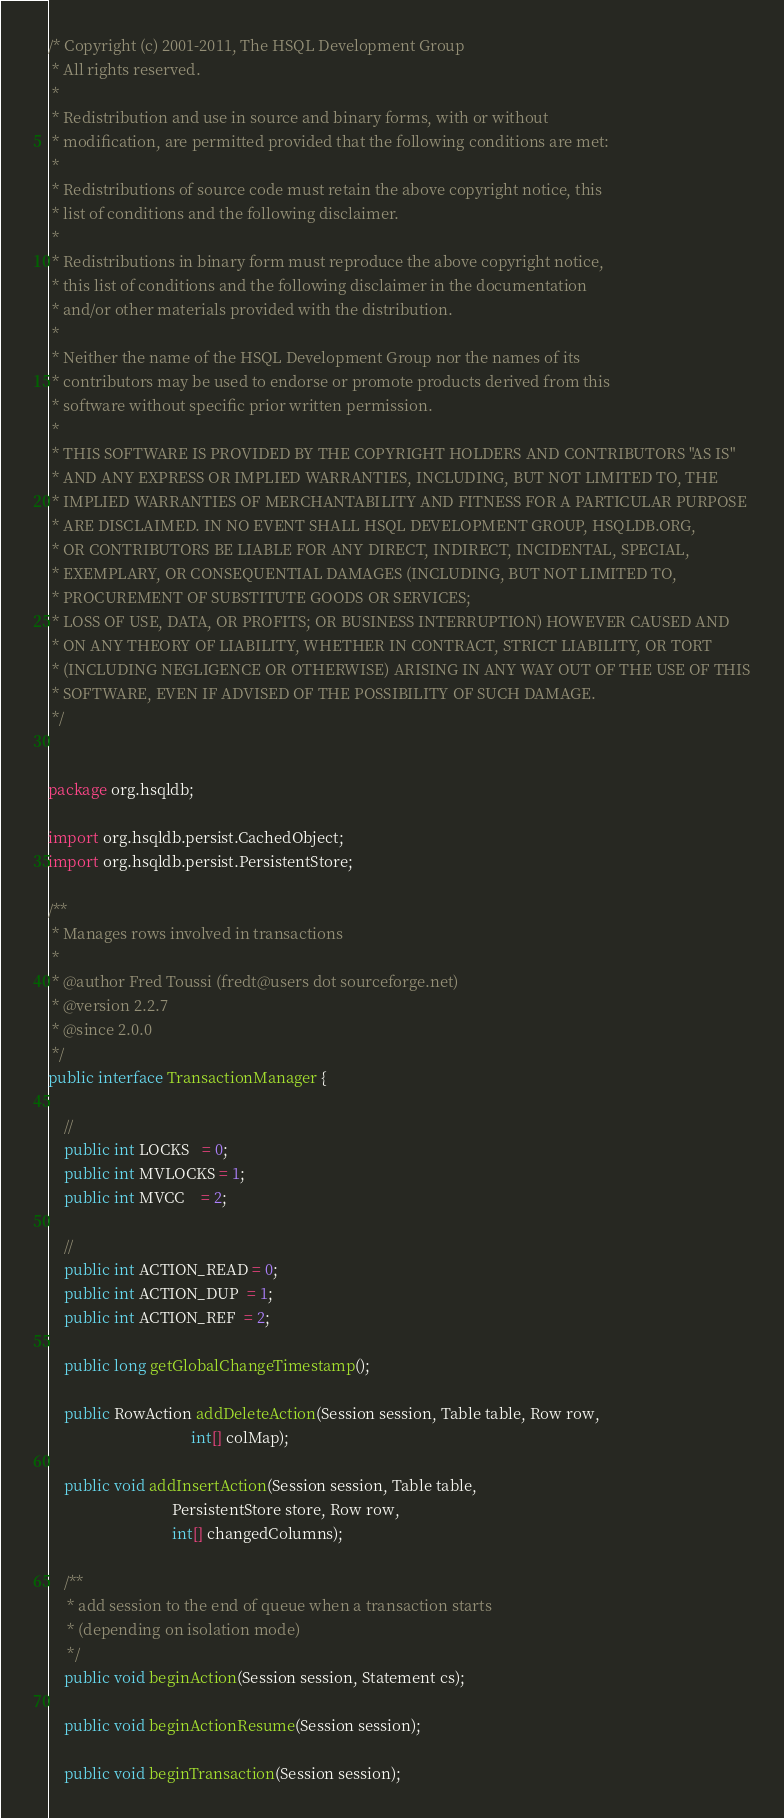Convert code to text. <code><loc_0><loc_0><loc_500><loc_500><_Java_>/* Copyright (c) 2001-2011, The HSQL Development Group
 * All rights reserved.
 *
 * Redistribution and use in source and binary forms, with or without
 * modification, are permitted provided that the following conditions are met:
 *
 * Redistributions of source code must retain the above copyright notice, this
 * list of conditions and the following disclaimer.
 *
 * Redistributions in binary form must reproduce the above copyright notice,
 * this list of conditions and the following disclaimer in the documentation
 * and/or other materials provided with the distribution.
 *
 * Neither the name of the HSQL Development Group nor the names of its
 * contributors may be used to endorse or promote products derived from this
 * software without specific prior written permission.
 *
 * THIS SOFTWARE IS PROVIDED BY THE COPYRIGHT HOLDERS AND CONTRIBUTORS "AS IS"
 * AND ANY EXPRESS OR IMPLIED WARRANTIES, INCLUDING, BUT NOT LIMITED TO, THE
 * IMPLIED WARRANTIES OF MERCHANTABILITY AND FITNESS FOR A PARTICULAR PURPOSE
 * ARE DISCLAIMED. IN NO EVENT SHALL HSQL DEVELOPMENT GROUP, HSQLDB.ORG,
 * OR CONTRIBUTORS BE LIABLE FOR ANY DIRECT, INDIRECT, INCIDENTAL, SPECIAL,
 * EXEMPLARY, OR CONSEQUENTIAL DAMAGES (INCLUDING, BUT NOT LIMITED TO,
 * PROCUREMENT OF SUBSTITUTE GOODS OR SERVICES;
 * LOSS OF USE, DATA, OR PROFITS; OR BUSINESS INTERRUPTION) HOWEVER CAUSED AND
 * ON ANY THEORY OF LIABILITY, WHETHER IN CONTRACT, STRICT LIABILITY, OR TORT
 * (INCLUDING NEGLIGENCE OR OTHERWISE) ARISING IN ANY WAY OUT OF THE USE OF THIS
 * SOFTWARE, EVEN IF ADVISED OF THE POSSIBILITY OF SUCH DAMAGE.
 */


package org.hsqldb;

import org.hsqldb.persist.CachedObject;
import org.hsqldb.persist.PersistentStore;

/**
 * Manages rows involved in transactions
 *
 * @author Fred Toussi (fredt@users dot sourceforge.net)
 * @version 2.2.7
 * @since 2.0.0
 */
public interface TransactionManager {

    //
    public int LOCKS   = 0;
    public int MVLOCKS = 1;
    public int MVCC    = 2;

    //
    public int ACTION_READ = 0;
    public int ACTION_DUP  = 1;
    public int ACTION_REF  = 2;

    public long getGlobalChangeTimestamp();

    public RowAction addDeleteAction(Session session, Table table, Row row,
                                     int[] colMap);

    public void addInsertAction(Session session, Table table,
                                PersistentStore store, Row row,
                                int[] changedColumns);

    /**
     * add session to the end of queue when a transaction starts
     * (depending on isolation mode)
     */
    public void beginAction(Session session, Statement cs);

    public void beginActionResume(Session session);

    public void beginTransaction(Session session);
</code> 